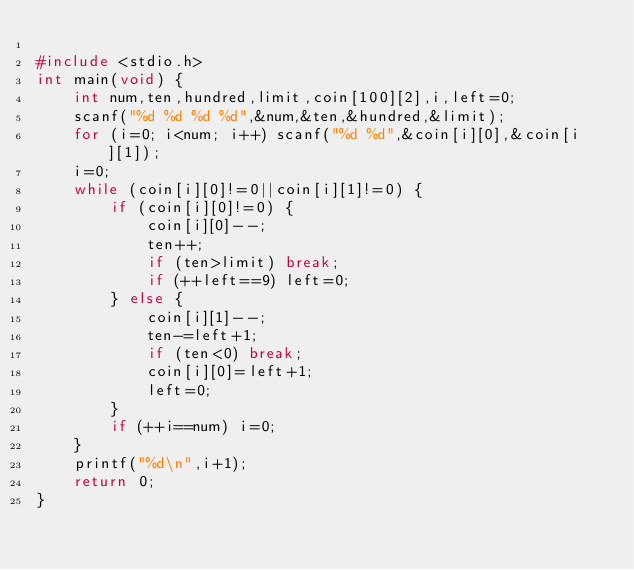Convert code to text. <code><loc_0><loc_0><loc_500><loc_500><_C_>
#include <stdio.h>
int main(void) {
    int num,ten,hundred,limit,coin[100][2],i,left=0;
    scanf("%d %d %d %d",&num,&ten,&hundred,&limit);
    for (i=0; i<num; i++) scanf("%d %d",&coin[i][0],&coin[i][1]);
    i=0;
    while (coin[i][0]!=0||coin[i][1]!=0) {
        if (coin[i][0]!=0) {
            coin[i][0]--;
            ten++;
            if (ten>limit) break;
            if (++left==9) left=0;
        } else {
            coin[i][1]--;
            ten-=left+1;
            if (ten<0) break;
            coin[i][0]=left+1;
            left=0;
        }
        if (++i==num) i=0;
    }
    printf("%d\n",i+1);
    return 0;
}</code> 